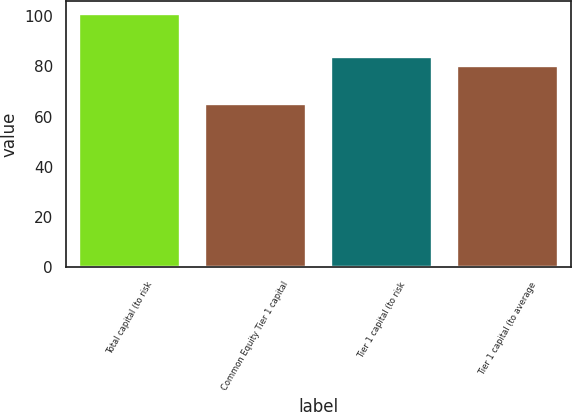Convert chart to OTSL. <chart><loc_0><loc_0><loc_500><loc_500><bar_chart><fcel>Total capital (to risk<fcel>Common Equity Tier 1 capital<fcel>Tier 1 capital (to risk<fcel>Tier 1 capital (to average<nl><fcel>101<fcel>65<fcel>83.6<fcel>80<nl></chart> 